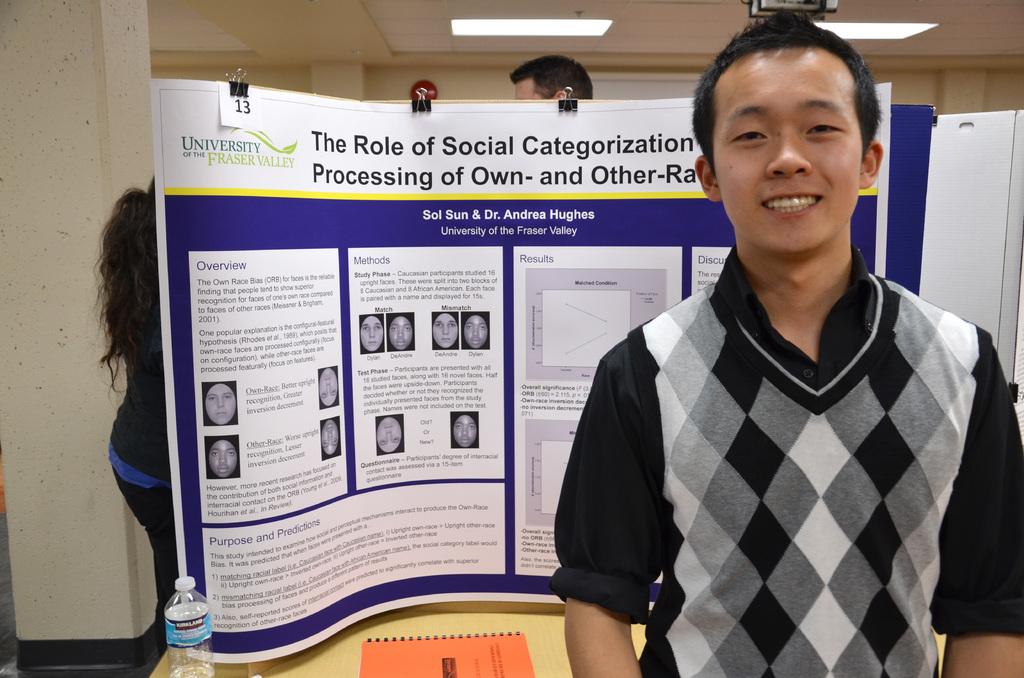What is the presentation about?
Make the answer very short. The role of social categorization. What school is on poster?
Your answer should be very brief. University of the fraser valley. 